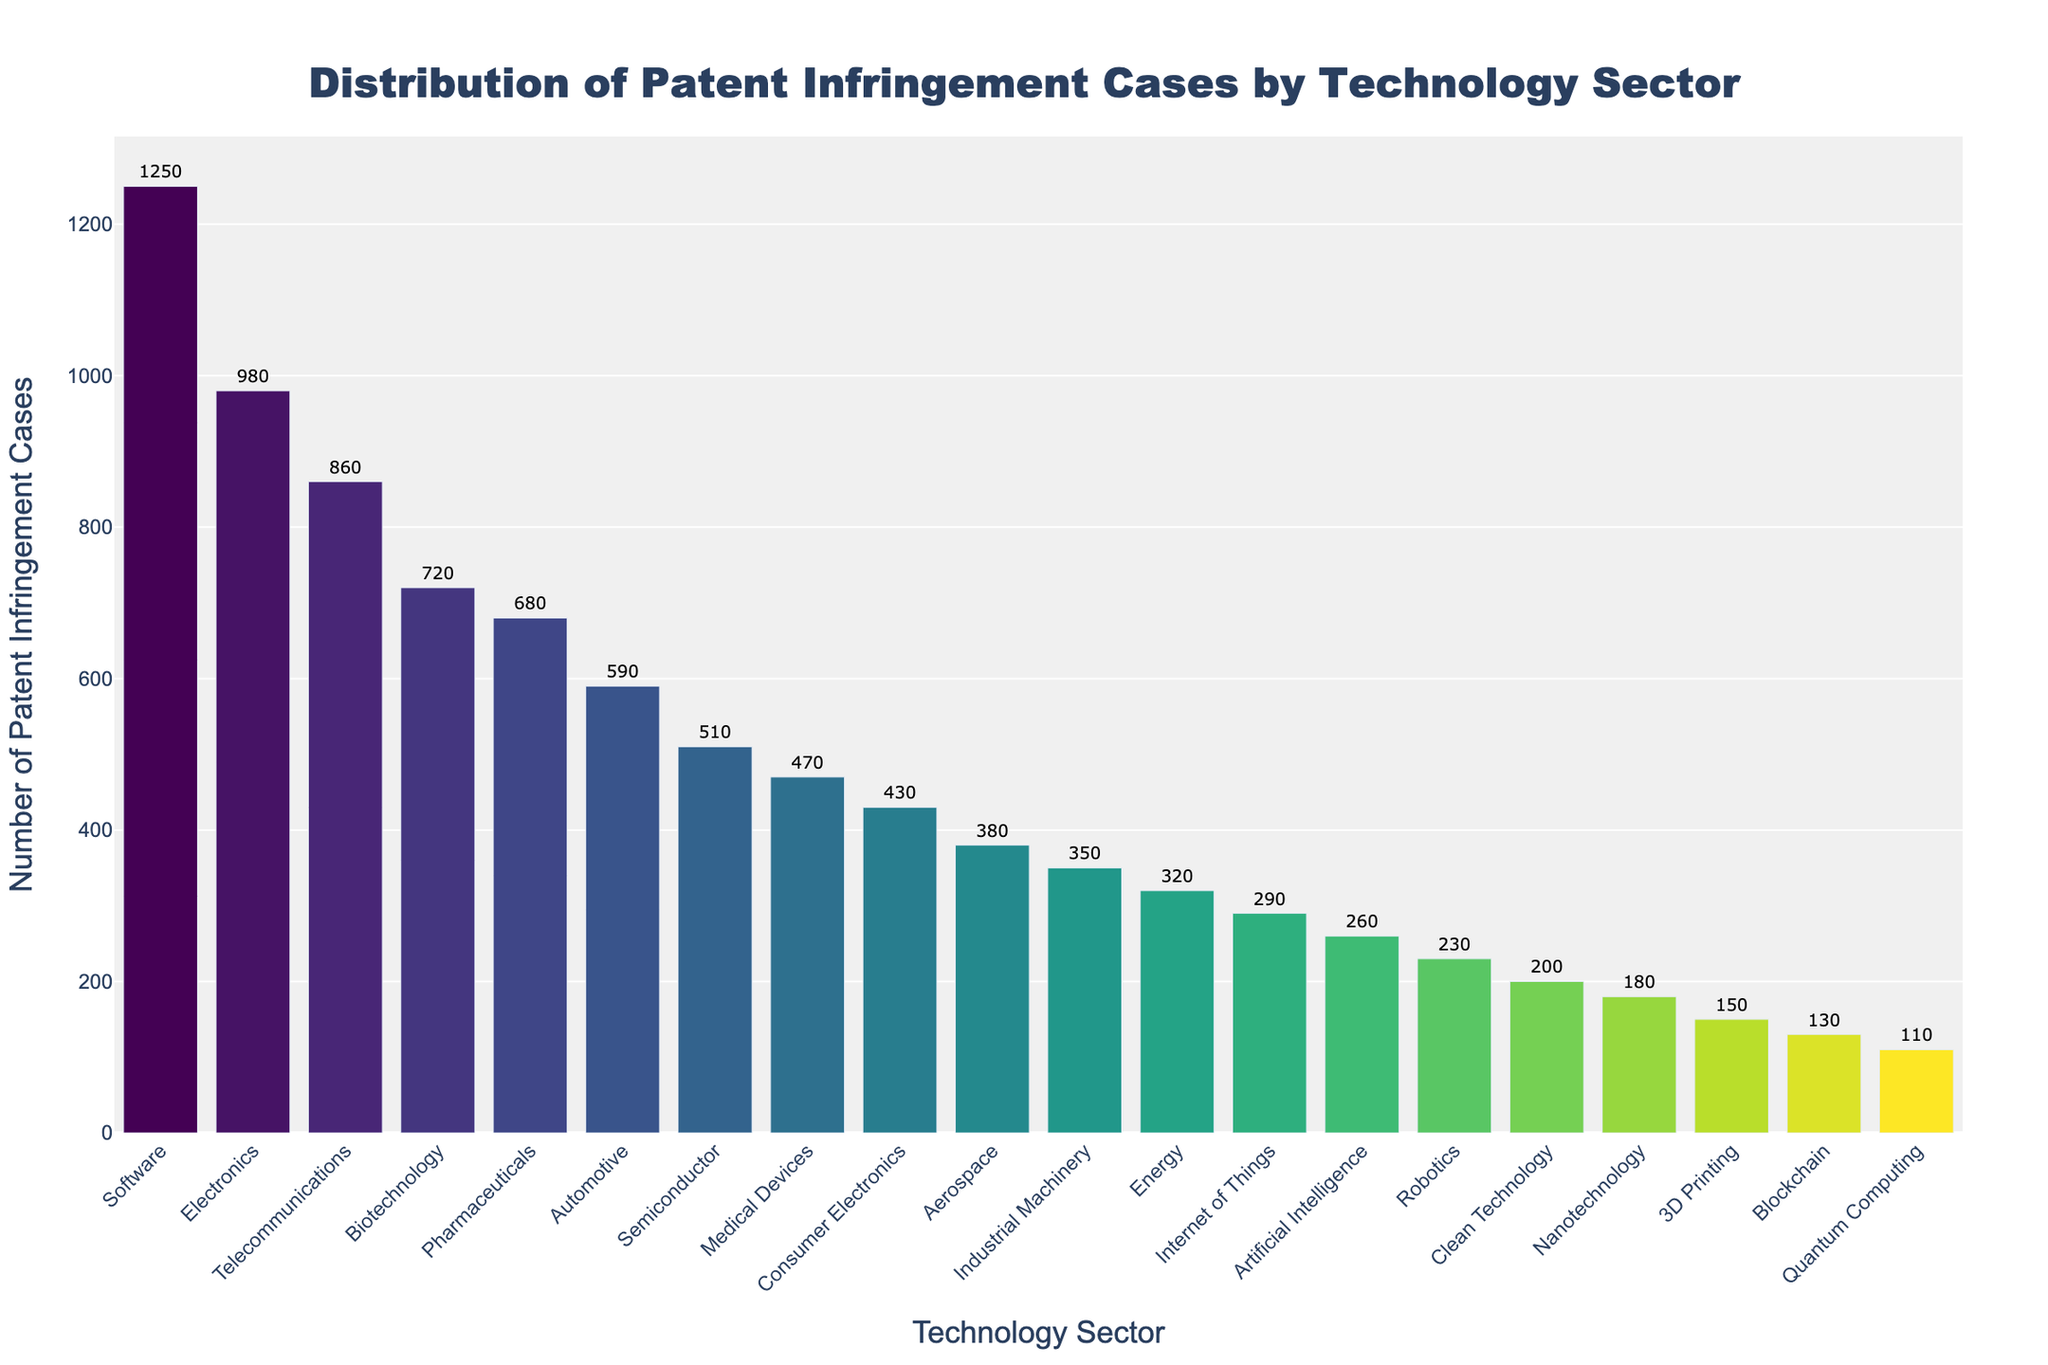Which technology sector has the highest number of patent infringement cases? By looking at the height of the bars, the "Software" sector has the tallest bar, indicating the highest number of cases.
Answer: Software Which technology sector has the fewest number of patent infringement cases? The shortest bar on the chart represents the "Quantum Computing" sector, which has the fewest cases.
Answer: Quantum Computing How many more patent infringement cases does the Software sector have compared to the Internet of Things sector? The Software sector has 1250 cases, while the Internet of Things sector has 290 cases. The difference is 1250 - 290.
Answer: 960 Which sectors have more than 700 patent infringement cases? Sectors with bars height indicating more than 700 cases include "Software," "Electronics," "Telecommunications," and "Biotechnology."
Answer: Software, Electronics, Telecommunications, Biotechnology What is the combined number of patent infringement cases in the Pharmaceuticals and Automotive sectors? The Pharmaceuticals sector has 680 cases and the Automotive sector has 590 cases. Adding these together gives 680 + 590.
Answer: 1270 Is the number of patent infringement cases in the Telecommunications sector greater than in the Semiconductor sector? The Telecommunications sector has 860 cases, while the Semiconductor sector has 510 cases. Since 860 is greater than 510, the answer is yes.
Answer: Yes What is the visual color gradient pattern used in the bar chart? The bars in the chart transition through various colors in the Viridis colorscale, starting with dark blue at the lowest values and transitioning to dark green and yellow at higher values.
Answer: Viridis colorscale How many sectors have fewer than 300 patent infringement cases? Counting the bars with heights denoting fewer than 300 cases includes "Internet of Things," "Artificial Intelligence," "Robotics," "Clean Technology," "Nanotechnology," "3D Printing," "Blockchain," "Quantum Computing."
Answer: 8 Which sector has a number of patent infringement cases closest to the mean of all sectors? Calculating the mean (or average) by summing all cases and dividing by the number of sectors: (1250+980+860+720+680+590+510+470+430+380+350+320+290+260+230+200+180+150+130+110)/20 = 46030/20 = 2301.5. The "Medical Devices" sector with 470 cases is closest.
Answer: Medical Devices 